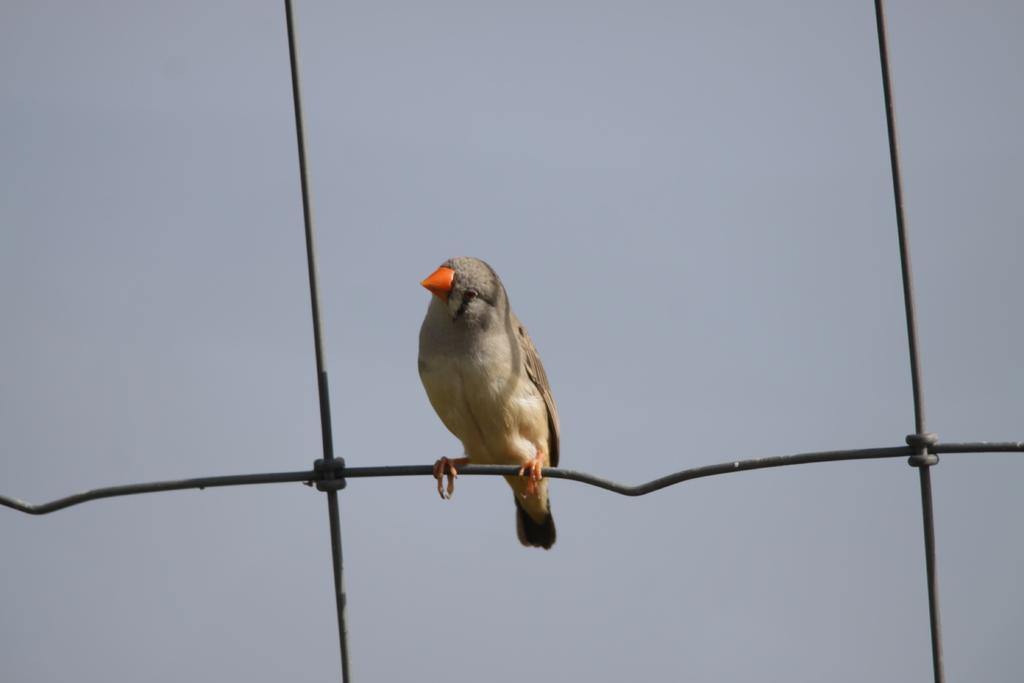What type of animal can be seen in the image? There is a bird in the image. Where is the bird located? The bird is on a wire. What can be seen in the background of the image? There is sky visible in the background of the image. What type of shame is the bird experiencing in the image? There is no indication of shame in the image; the bird is simply perched on a wire. 